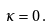Convert formula to latex. <formula><loc_0><loc_0><loc_500><loc_500>\kappa = 0 \, .</formula> 